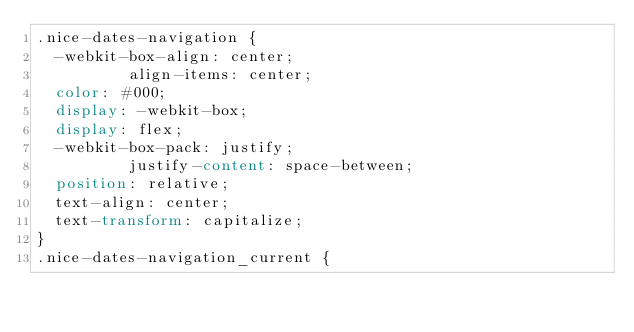Convert code to text. <code><loc_0><loc_0><loc_500><loc_500><_CSS_>.nice-dates-navigation {
  -webkit-box-align: center;
          align-items: center;
  color: #000;
  display: -webkit-box;
  display: flex;
  -webkit-box-pack: justify;
          justify-content: space-between;
  position: relative;
  text-align: center;
  text-transform: capitalize;
}
.nice-dates-navigation_current {</code> 